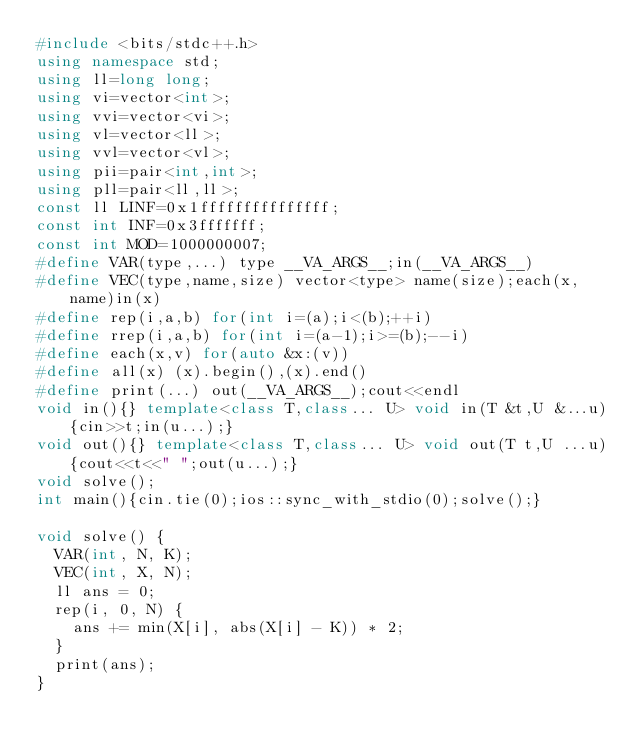Convert code to text. <code><loc_0><loc_0><loc_500><loc_500><_C++_>#include <bits/stdc++.h>
using namespace std;
using ll=long long;
using vi=vector<int>;
using vvi=vector<vi>;
using vl=vector<ll>;
using vvl=vector<vl>;
using pii=pair<int,int>;
using pll=pair<ll,ll>;
const ll LINF=0x1fffffffffffffff;
const int INF=0x3fffffff;
const int MOD=1000000007;
#define VAR(type,...) type __VA_ARGS__;in(__VA_ARGS__)
#define VEC(type,name,size) vector<type> name(size);each(x, name)in(x)
#define rep(i,a,b) for(int i=(a);i<(b);++i)
#define rrep(i,a,b) for(int i=(a-1);i>=(b);--i)
#define each(x,v) for(auto &x:(v))
#define all(x) (x).begin(),(x).end()
#define print(...) out(__VA_ARGS__);cout<<endl
void in(){} template<class T,class... U> void in(T &t,U &...u){cin>>t;in(u...);}
void out(){} template<class T,class... U> void out(T t,U ...u){cout<<t<<" ";out(u...);}
void solve();
int main(){cin.tie(0);ios::sync_with_stdio(0);solve();}

void solve() {
  VAR(int, N, K);
  VEC(int, X, N);
  ll ans = 0;
  rep(i, 0, N) {
    ans += min(X[i], abs(X[i] - K)) * 2;
  }
  print(ans);
}
</code> 